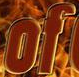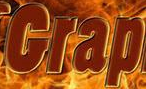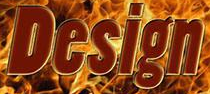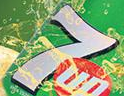What text is displayed in these images sequentially, separated by a semicolon? of; Grap; Design; 7 